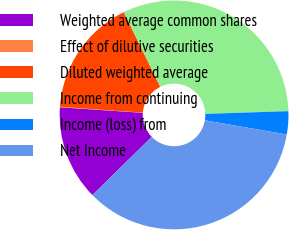<chart> <loc_0><loc_0><loc_500><loc_500><pie_chart><fcel>Weighted average common shares<fcel>Effect of dilutive securities<fcel>Diluted weighted average<fcel>Income from continuing<fcel>Income (loss) from<fcel>Net Income<nl><fcel>13.42%<fcel>0.07%<fcel>16.61%<fcel>31.72%<fcel>3.26%<fcel>34.91%<nl></chart> 